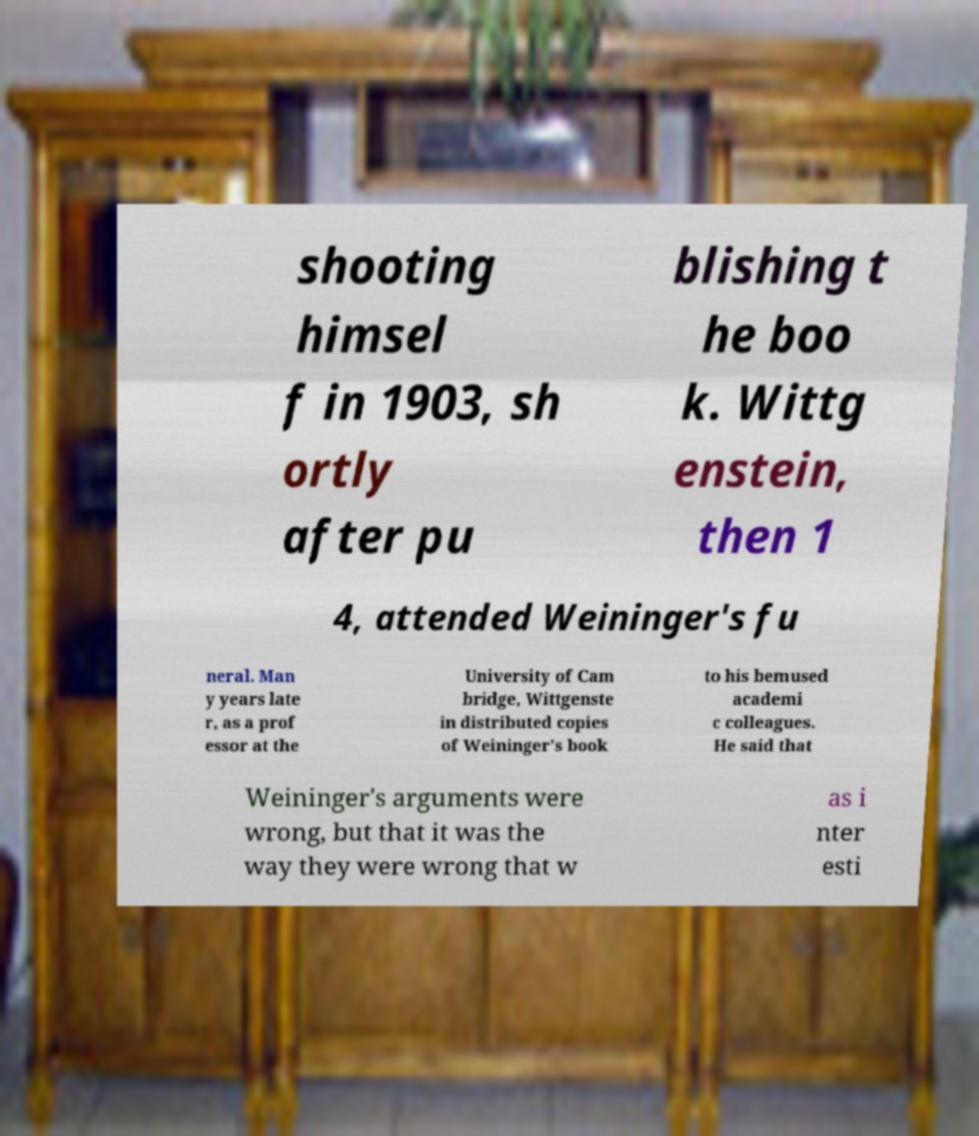Please identify and transcribe the text found in this image. shooting himsel f in 1903, sh ortly after pu blishing t he boo k. Wittg enstein, then 1 4, attended Weininger's fu neral. Man y years late r, as a prof essor at the University of Cam bridge, Wittgenste in distributed copies of Weininger's book to his bemused academi c colleagues. He said that Weininger's arguments were wrong, but that it was the way they were wrong that w as i nter esti 